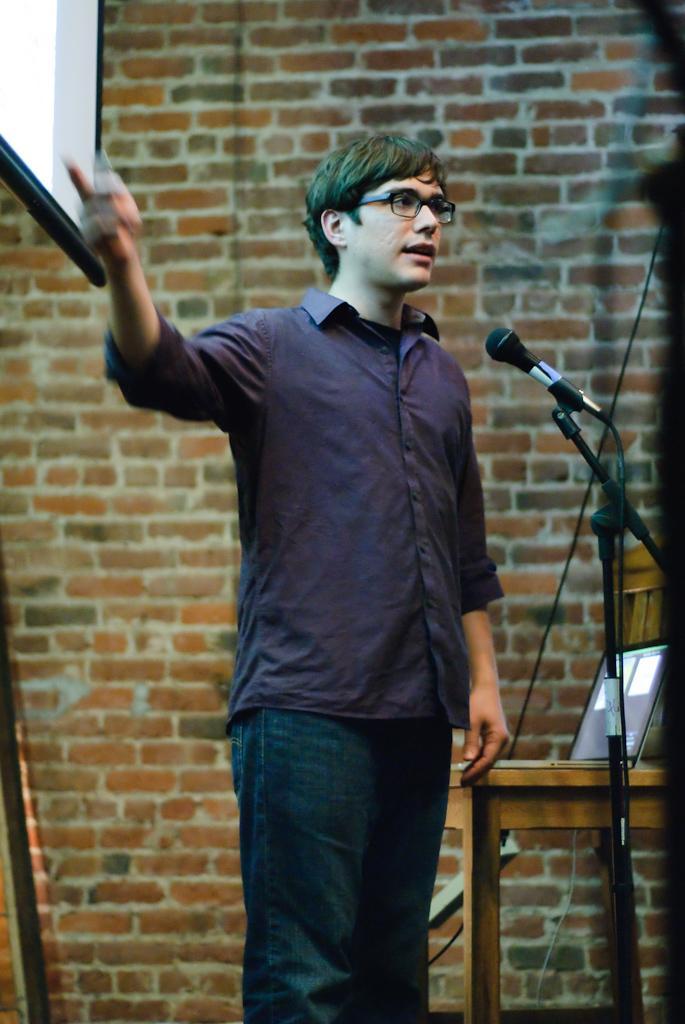Please provide a concise description of this image. In this picture we can observe a person standing, wearing a violet color shirt in front of a mic and a stand. He is wearing spectacles. We can observe a table on which a laptop is placed. There is a projector display screen on the left side. In the background there is a wall. 